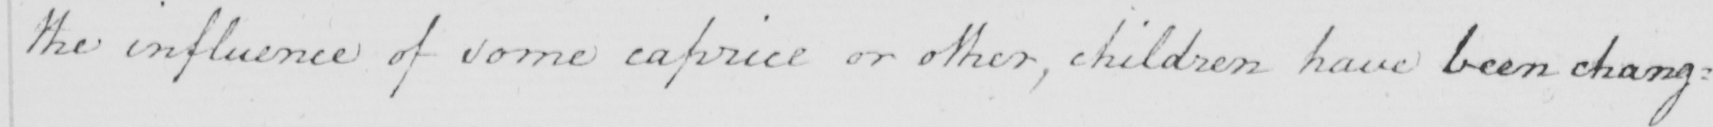Please transcribe the handwritten text in this image. the influence of some caprice or other , children have been chang= 